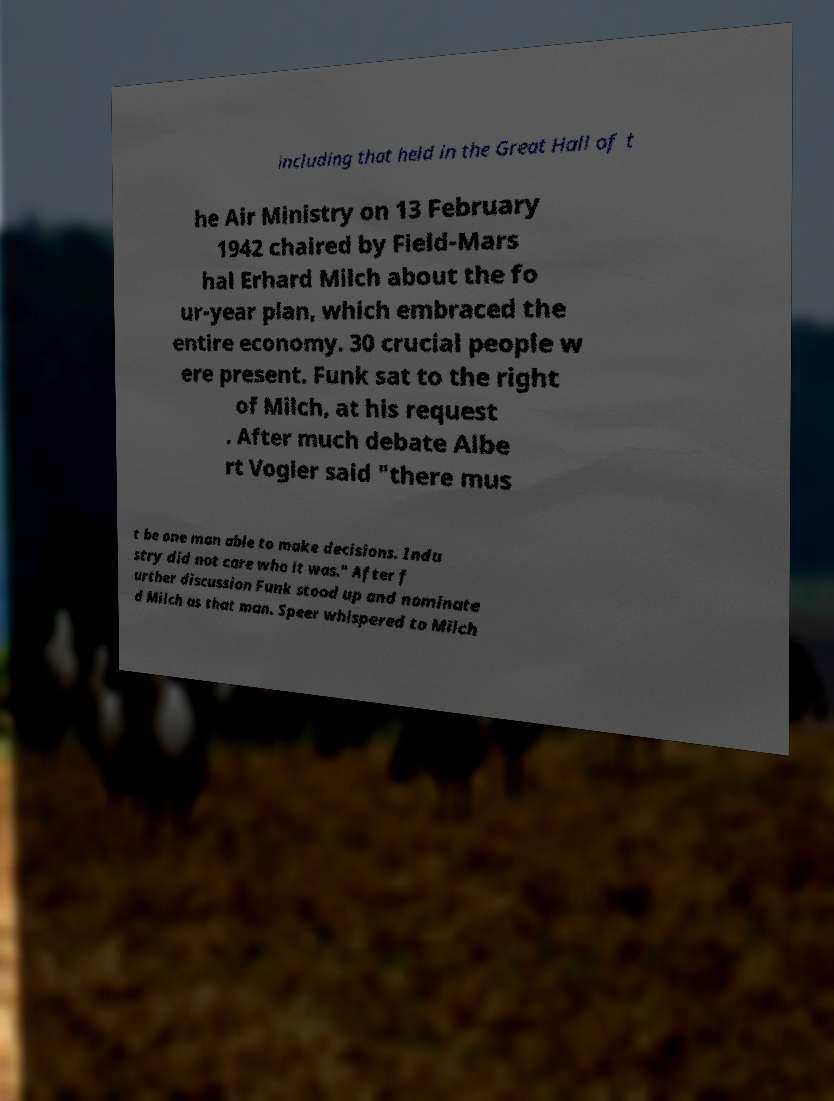Could you assist in decoding the text presented in this image and type it out clearly? including that held in the Great Hall of t he Air Ministry on 13 February 1942 chaired by Field-Mars hal Erhard Milch about the fo ur-year plan, which embraced the entire economy. 30 crucial people w ere present. Funk sat to the right of Milch, at his request . After much debate Albe rt Vogler said "there mus t be one man able to make decisions. Indu stry did not care who it was." After f urther discussion Funk stood up and nominate d Milch as that man. Speer whispered to Milch 